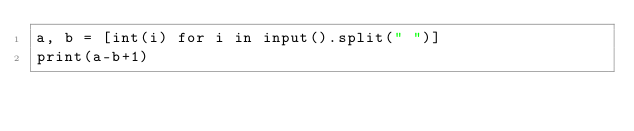<code> <loc_0><loc_0><loc_500><loc_500><_Python_>a, b = [int(i) for i in input().split(" ")]
print(a-b+1)</code> 